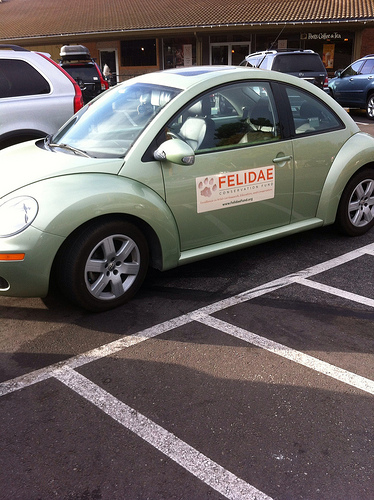<image>
Is the car in the road? No. The car is not contained within the road. These objects have a different spatial relationship. 